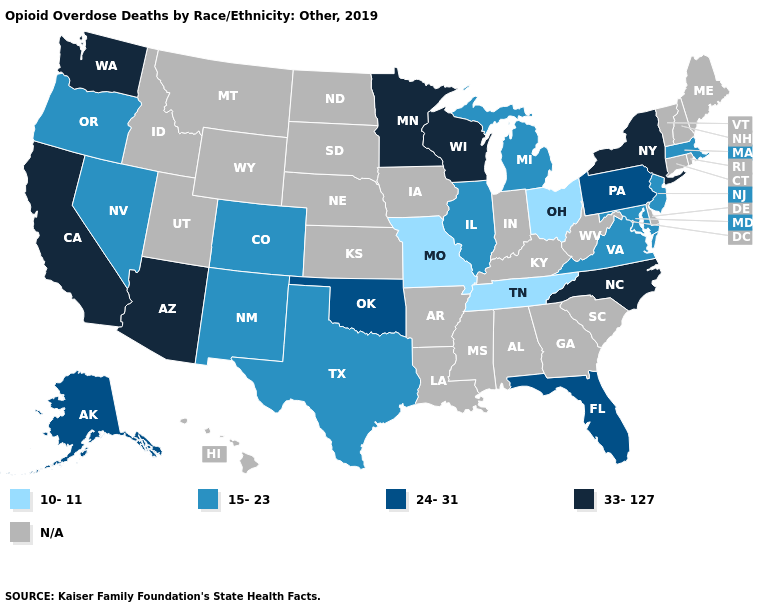Name the states that have a value in the range 24-31?
Answer briefly. Alaska, Florida, Oklahoma, Pennsylvania. What is the value of Nevada?
Be succinct. 15-23. Which states hav the highest value in the West?
Give a very brief answer. Arizona, California, Washington. Does the map have missing data?
Be succinct. Yes. Does the first symbol in the legend represent the smallest category?
Answer briefly. Yes. Does the map have missing data?
Quick response, please. Yes. What is the highest value in the USA?
Write a very short answer. 33-127. What is the value of Mississippi?
Keep it brief. N/A. Name the states that have a value in the range 33-127?
Answer briefly. Arizona, California, Minnesota, New York, North Carolina, Washington, Wisconsin. What is the value of Washington?
Concise answer only. 33-127. Name the states that have a value in the range 10-11?
Short answer required. Missouri, Ohio, Tennessee. How many symbols are there in the legend?
Short answer required. 5. What is the lowest value in the MidWest?
Write a very short answer. 10-11. 